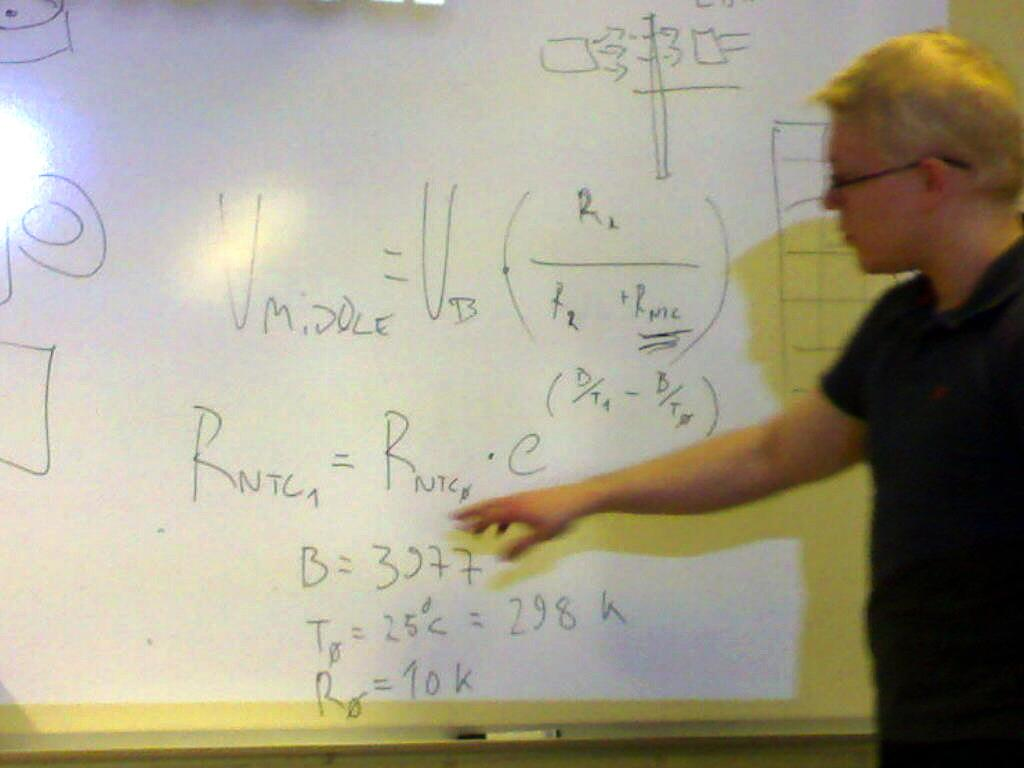<image>
Give a short and clear explanation of the subsequent image. A man pointing at a white board which contains the letters RNTC. 